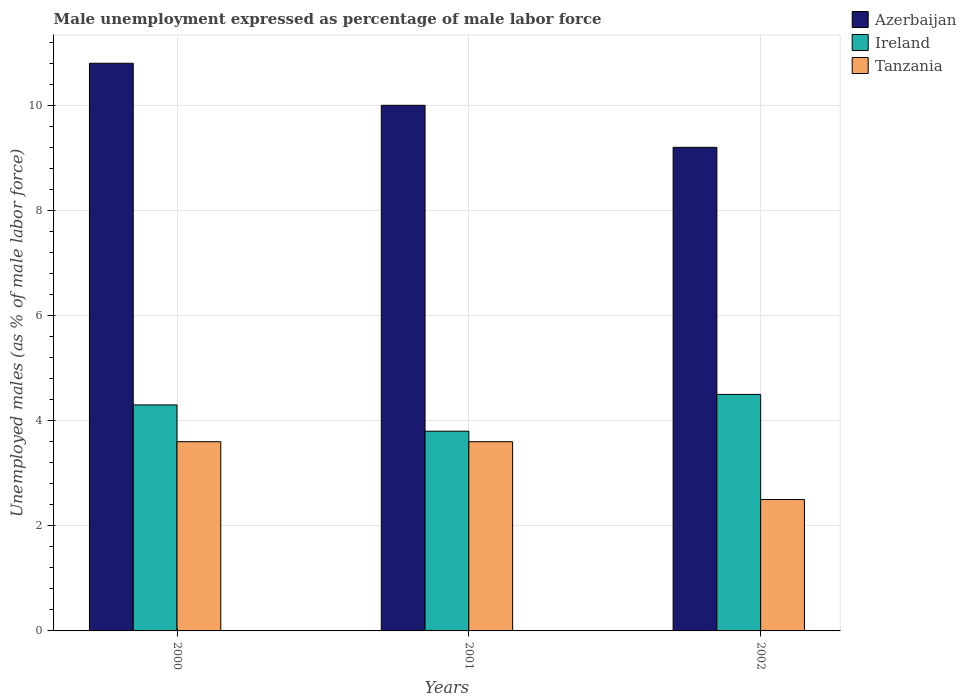How many different coloured bars are there?
Keep it short and to the point. 3. Are the number of bars on each tick of the X-axis equal?
Make the answer very short. Yes. How many bars are there on the 1st tick from the left?
Give a very brief answer. 3. How many bars are there on the 1st tick from the right?
Offer a very short reply. 3. In how many cases, is the number of bars for a given year not equal to the number of legend labels?
Provide a short and direct response. 0. Across all years, what is the minimum unemployment in males in in Tanzania?
Provide a short and direct response. 2.5. In which year was the unemployment in males in in Tanzania maximum?
Provide a succinct answer. 2000. In which year was the unemployment in males in in Tanzania minimum?
Offer a terse response. 2002. What is the total unemployment in males in in Azerbaijan in the graph?
Offer a very short reply. 30. What is the difference between the unemployment in males in in Tanzania in 2001 and that in 2002?
Offer a very short reply. 1.1. What is the difference between the unemployment in males in in Tanzania in 2001 and the unemployment in males in in Ireland in 2002?
Ensure brevity in your answer.  -0.9. What is the average unemployment in males in in Tanzania per year?
Your answer should be compact. 3.23. In the year 2001, what is the difference between the unemployment in males in in Ireland and unemployment in males in in Tanzania?
Your answer should be very brief. 0.2. In how many years, is the unemployment in males in in Ireland greater than 9.2 %?
Provide a succinct answer. 0. What is the ratio of the unemployment in males in in Ireland in 2000 to that in 2002?
Offer a very short reply. 0.96. Is the difference between the unemployment in males in in Ireland in 2000 and 2002 greater than the difference between the unemployment in males in in Tanzania in 2000 and 2002?
Ensure brevity in your answer.  No. What is the difference between the highest and the second highest unemployment in males in in Ireland?
Offer a terse response. 0.2. What is the difference between the highest and the lowest unemployment in males in in Tanzania?
Offer a very short reply. 1.1. Is the sum of the unemployment in males in in Ireland in 2000 and 2002 greater than the maximum unemployment in males in in Azerbaijan across all years?
Offer a terse response. No. What does the 3rd bar from the left in 2002 represents?
Provide a succinct answer. Tanzania. What does the 3rd bar from the right in 2002 represents?
Offer a very short reply. Azerbaijan. Is it the case that in every year, the sum of the unemployment in males in in Tanzania and unemployment in males in in Azerbaijan is greater than the unemployment in males in in Ireland?
Your response must be concise. Yes. What is the difference between two consecutive major ticks on the Y-axis?
Offer a very short reply. 2. Are the values on the major ticks of Y-axis written in scientific E-notation?
Offer a very short reply. No. Does the graph contain any zero values?
Provide a succinct answer. No. How are the legend labels stacked?
Offer a very short reply. Vertical. What is the title of the graph?
Give a very brief answer. Male unemployment expressed as percentage of male labor force. Does "Ireland" appear as one of the legend labels in the graph?
Make the answer very short. Yes. What is the label or title of the Y-axis?
Provide a short and direct response. Unemployed males (as % of male labor force). What is the Unemployed males (as % of male labor force) in Azerbaijan in 2000?
Give a very brief answer. 10.8. What is the Unemployed males (as % of male labor force) in Ireland in 2000?
Offer a terse response. 4.3. What is the Unemployed males (as % of male labor force) of Tanzania in 2000?
Provide a succinct answer. 3.6. What is the Unemployed males (as % of male labor force) in Ireland in 2001?
Provide a short and direct response. 3.8. What is the Unemployed males (as % of male labor force) of Tanzania in 2001?
Give a very brief answer. 3.6. What is the Unemployed males (as % of male labor force) of Azerbaijan in 2002?
Provide a short and direct response. 9.2. What is the Unemployed males (as % of male labor force) of Tanzania in 2002?
Make the answer very short. 2.5. Across all years, what is the maximum Unemployed males (as % of male labor force) of Azerbaijan?
Offer a terse response. 10.8. Across all years, what is the maximum Unemployed males (as % of male labor force) of Ireland?
Offer a very short reply. 4.5. Across all years, what is the maximum Unemployed males (as % of male labor force) in Tanzania?
Make the answer very short. 3.6. Across all years, what is the minimum Unemployed males (as % of male labor force) in Azerbaijan?
Make the answer very short. 9.2. Across all years, what is the minimum Unemployed males (as % of male labor force) of Ireland?
Your response must be concise. 3.8. What is the difference between the Unemployed males (as % of male labor force) of Azerbaijan in 2000 and that in 2001?
Your response must be concise. 0.8. What is the difference between the Unemployed males (as % of male labor force) in Azerbaijan in 2000 and that in 2002?
Ensure brevity in your answer.  1.6. What is the difference between the Unemployed males (as % of male labor force) in Ireland in 2000 and that in 2002?
Offer a terse response. -0.2. What is the difference between the Unemployed males (as % of male labor force) in Tanzania in 2000 and that in 2002?
Your answer should be very brief. 1.1. What is the difference between the Unemployed males (as % of male labor force) of Azerbaijan in 2001 and that in 2002?
Ensure brevity in your answer.  0.8. What is the difference between the Unemployed males (as % of male labor force) of Ireland in 2001 and that in 2002?
Keep it short and to the point. -0.7. What is the difference between the Unemployed males (as % of male labor force) of Tanzania in 2001 and that in 2002?
Make the answer very short. 1.1. What is the difference between the Unemployed males (as % of male labor force) of Azerbaijan in 2000 and the Unemployed males (as % of male labor force) of Ireland in 2001?
Offer a very short reply. 7. What is the difference between the Unemployed males (as % of male labor force) in Ireland in 2000 and the Unemployed males (as % of male labor force) in Tanzania in 2001?
Provide a succinct answer. 0.7. What is the difference between the Unemployed males (as % of male labor force) in Azerbaijan in 2000 and the Unemployed males (as % of male labor force) in Tanzania in 2002?
Provide a succinct answer. 8.3. What is the difference between the Unemployed males (as % of male labor force) in Azerbaijan in 2001 and the Unemployed males (as % of male labor force) in Tanzania in 2002?
Your response must be concise. 7.5. What is the average Unemployed males (as % of male labor force) in Azerbaijan per year?
Offer a terse response. 10. What is the average Unemployed males (as % of male labor force) of Tanzania per year?
Provide a succinct answer. 3.23. In the year 2000, what is the difference between the Unemployed males (as % of male labor force) of Azerbaijan and Unemployed males (as % of male labor force) of Tanzania?
Give a very brief answer. 7.2. In the year 2000, what is the difference between the Unemployed males (as % of male labor force) of Ireland and Unemployed males (as % of male labor force) of Tanzania?
Offer a terse response. 0.7. In the year 2001, what is the difference between the Unemployed males (as % of male labor force) in Azerbaijan and Unemployed males (as % of male labor force) in Tanzania?
Keep it short and to the point. 6.4. In the year 2002, what is the difference between the Unemployed males (as % of male labor force) of Azerbaijan and Unemployed males (as % of male labor force) of Ireland?
Offer a very short reply. 4.7. In the year 2002, what is the difference between the Unemployed males (as % of male labor force) of Azerbaijan and Unemployed males (as % of male labor force) of Tanzania?
Keep it short and to the point. 6.7. What is the ratio of the Unemployed males (as % of male labor force) of Ireland in 2000 to that in 2001?
Make the answer very short. 1.13. What is the ratio of the Unemployed males (as % of male labor force) of Azerbaijan in 2000 to that in 2002?
Your answer should be very brief. 1.17. What is the ratio of the Unemployed males (as % of male labor force) in Ireland in 2000 to that in 2002?
Give a very brief answer. 0.96. What is the ratio of the Unemployed males (as % of male labor force) in Tanzania in 2000 to that in 2002?
Make the answer very short. 1.44. What is the ratio of the Unemployed males (as % of male labor force) in Azerbaijan in 2001 to that in 2002?
Ensure brevity in your answer.  1.09. What is the ratio of the Unemployed males (as % of male labor force) of Ireland in 2001 to that in 2002?
Your answer should be compact. 0.84. What is the ratio of the Unemployed males (as % of male labor force) of Tanzania in 2001 to that in 2002?
Keep it short and to the point. 1.44. What is the difference between the highest and the second highest Unemployed males (as % of male labor force) in Azerbaijan?
Your response must be concise. 0.8. What is the difference between the highest and the second highest Unemployed males (as % of male labor force) of Ireland?
Make the answer very short. 0.2. What is the difference between the highest and the lowest Unemployed males (as % of male labor force) of Azerbaijan?
Your answer should be compact. 1.6. 